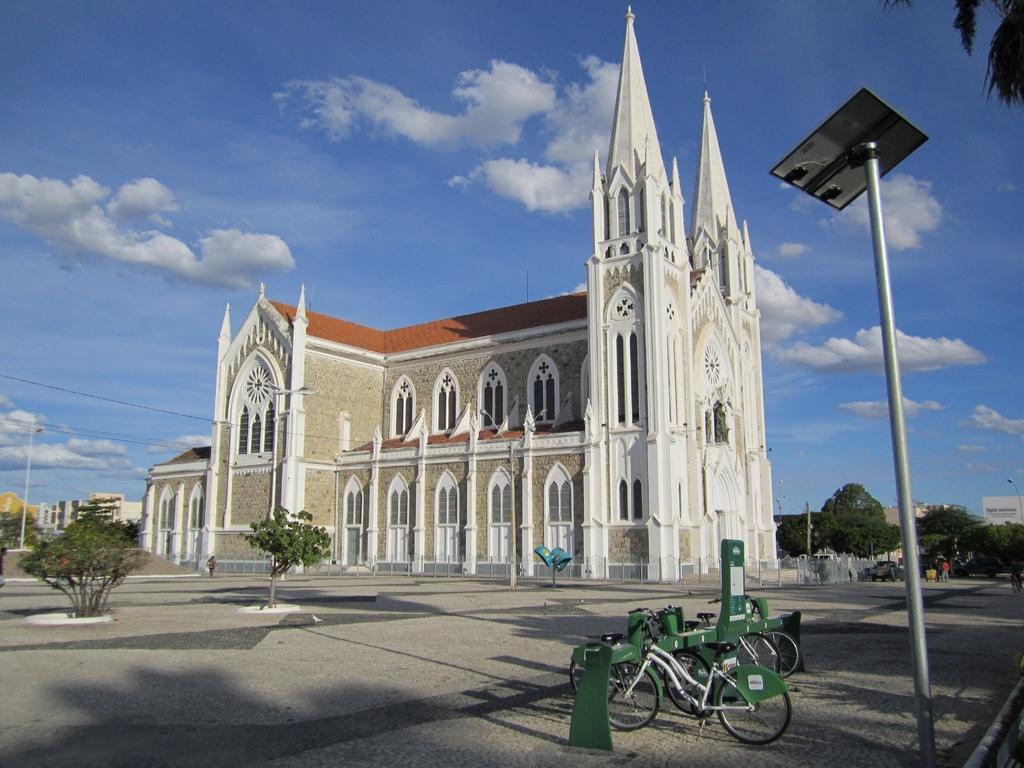Please provide a concise description of this image. In the image on the right side we can see poles and cycles. In the background we can see sky,clouds,trees,buildings,wall,roof,windows,road,sign board,one person standing etc. 